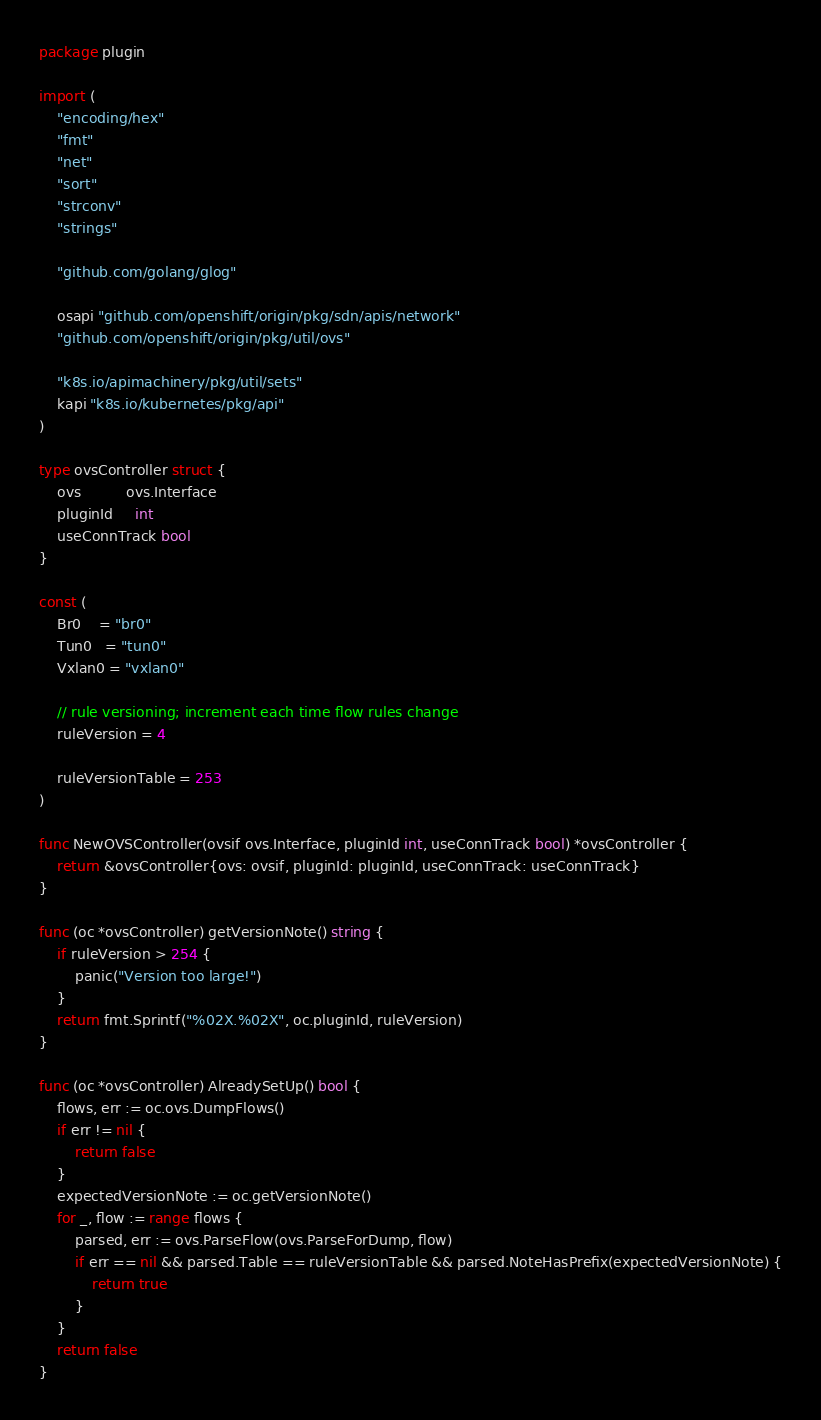<code> <loc_0><loc_0><loc_500><loc_500><_Go_>package plugin

import (
	"encoding/hex"
	"fmt"
	"net"
	"sort"
	"strconv"
	"strings"

	"github.com/golang/glog"

	osapi "github.com/openshift/origin/pkg/sdn/apis/network"
	"github.com/openshift/origin/pkg/util/ovs"

	"k8s.io/apimachinery/pkg/util/sets"
	kapi "k8s.io/kubernetes/pkg/api"
)

type ovsController struct {
	ovs          ovs.Interface
	pluginId     int
	useConnTrack bool
}

const (
	Br0    = "br0"
	Tun0   = "tun0"
	Vxlan0 = "vxlan0"

	// rule versioning; increment each time flow rules change
	ruleVersion = 4

	ruleVersionTable = 253
)

func NewOVSController(ovsif ovs.Interface, pluginId int, useConnTrack bool) *ovsController {
	return &ovsController{ovs: ovsif, pluginId: pluginId, useConnTrack: useConnTrack}
}

func (oc *ovsController) getVersionNote() string {
	if ruleVersion > 254 {
		panic("Version too large!")
	}
	return fmt.Sprintf("%02X.%02X", oc.pluginId, ruleVersion)
}

func (oc *ovsController) AlreadySetUp() bool {
	flows, err := oc.ovs.DumpFlows()
	if err != nil {
		return false
	}
	expectedVersionNote := oc.getVersionNote()
	for _, flow := range flows {
		parsed, err := ovs.ParseFlow(ovs.ParseForDump, flow)
		if err == nil && parsed.Table == ruleVersionTable && parsed.NoteHasPrefix(expectedVersionNote) {
			return true
		}
	}
	return false
}
</code> 